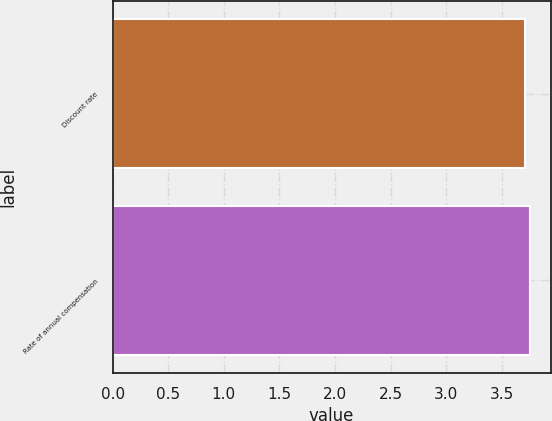<chart> <loc_0><loc_0><loc_500><loc_500><bar_chart><fcel>Discount rate<fcel>Rate of annual compensation<nl><fcel>3.71<fcel>3.75<nl></chart> 